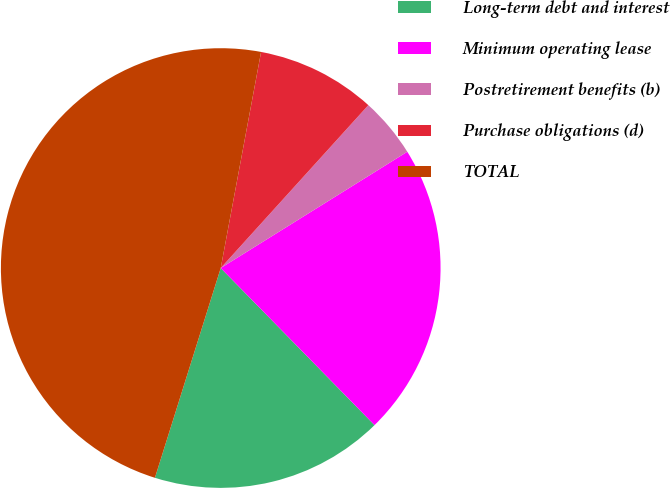<chart> <loc_0><loc_0><loc_500><loc_500><pie_chart><fcel>Long-term debt and interest<fcel>Minimum operating lease<fcel>Postretirement benefits (b)<fcel>Purchase obligations (d)<fcel>TOTAL<nl><fcel>17.17%<fcel>21.54%<fcel>4.41%<fcel>8.78%<fcel>48.1%<nl></chart> 